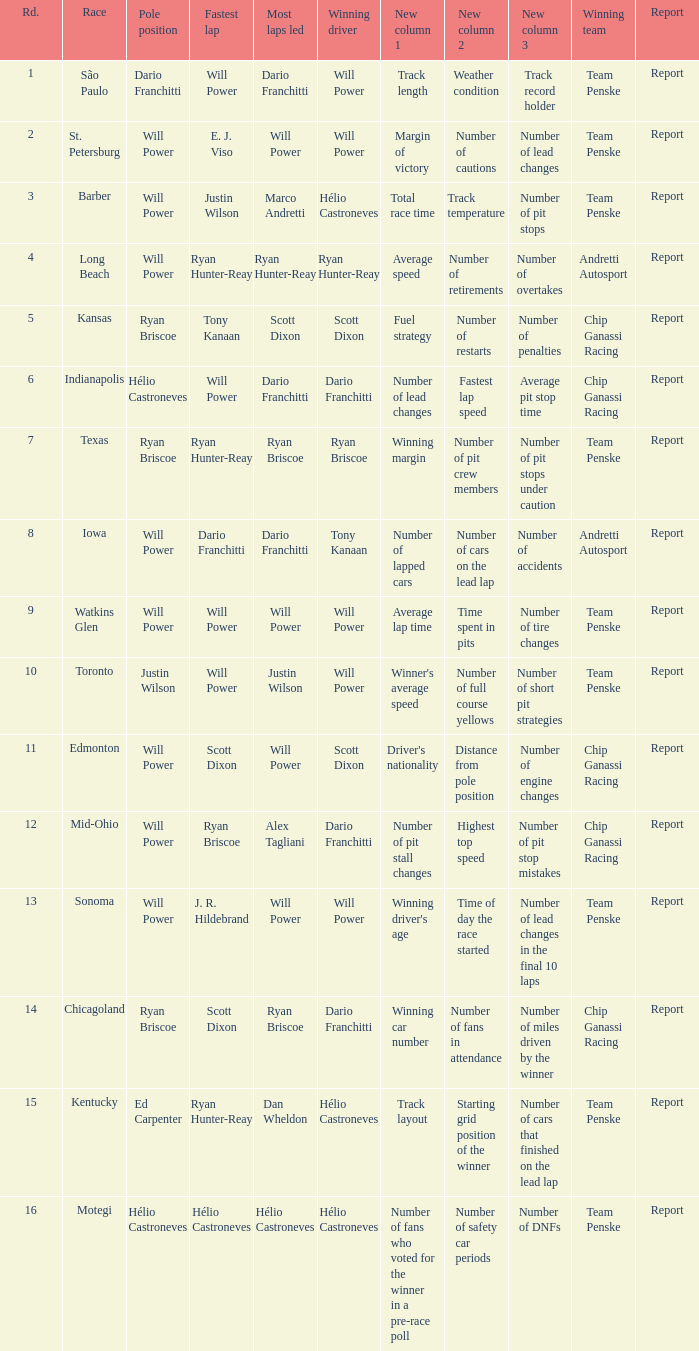In what position did the winning driver finish at Chicagoland? 1.0. 